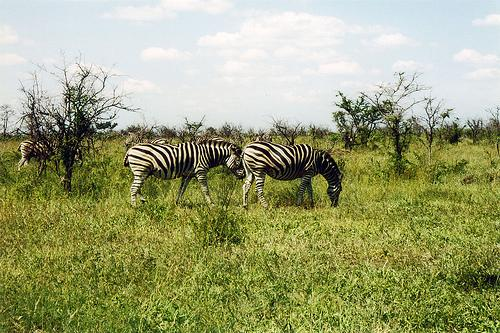Question: what kind of animals are photographed?
Choices:
A. Elephants.
B. Cows.
C. Horses.
D. Zebras.
Answer with the letter. Answer: D Question: what are the animals eating?
Choices:
A. Grass.
B. Leaves.
C. Food.
D. Nutriants.
Answer with the letter. Answer: A Question: how does the sky look?
Choices:
A. Dark.
B. Rainy.
C. Hazy.
D. Mostly cloudy.
Answer with the letter. Answer: D Question: what are the patterns on these animals?
Choices:
A. Different.
B. Black and white.
C. Square.
D. Stripes.
Answer with the letter. Answer: D Question: where is this picture taken?
Choices:
A. Outside.
B. Out in the wild.
C. Near trees.
D. With animals around.
Answer with the letter. Answer: B Question: how many zebras are visible?
Choices:
A. 2.
B. 4.
C. 3.
D. 5.
Answer with the letter. Answer: C 